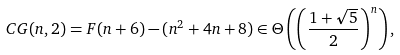<formula> <loc_0><loc_0><loc_500><loc_500>C G ( n , 2 ) = F ( n + 6 ) - ( n ^ { 2 } + 4 n + 8 ) \in \Theta \left ( \left ( \frac { 1 + \sqrt { 5 } } { 2 } \right ) ^ { n } \right ) ,</formula> 